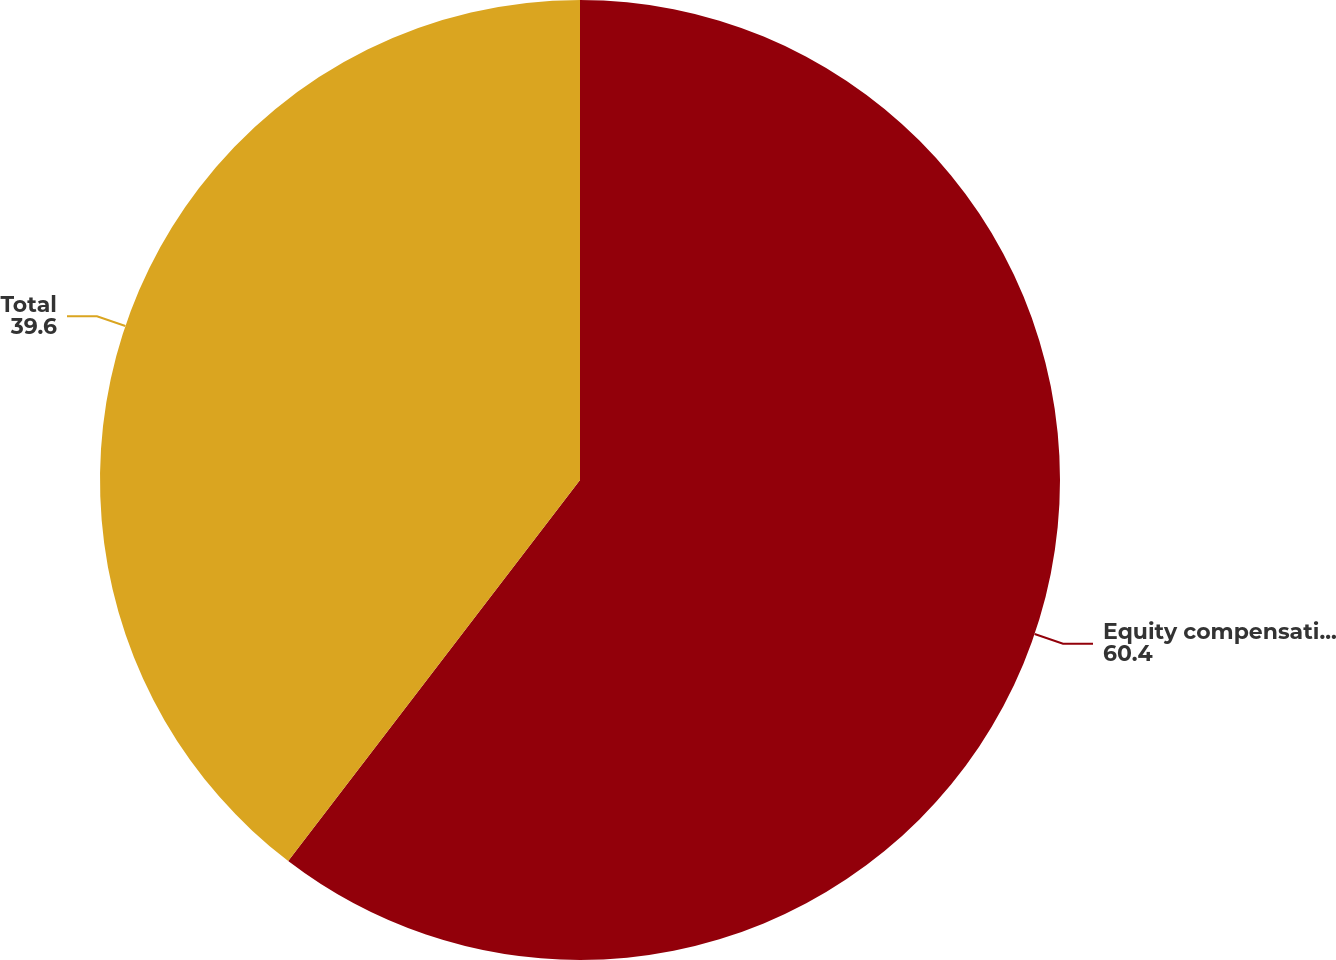Convert chart to OTSL. <chart><loc_0><loc_0><loc_500><loc_500><pie_chart><fcel>Equity compensation plans<fcel>Total<nl><fcel>60.4%<fcel>39.6%<nl></chart> 